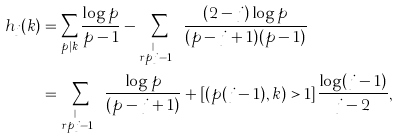Convert formula to latex. <formula><loc_0><loc_0><loc_500><loc_500>h _ { j } ( k ) & = \sum _ { p | k } \frac { \log p } { p - 1 } - \sum _ { \stackrel { r p | k } { r p \neq j - 1 } } \frac { ( 2 - j ) \log p } { ( p - j + 1 ) ( p - 1 ) } \\ & = \sum _ { \stackrel { r p | k } { r p \neq j - 1 } } \frac { \log p } { ( p - j + 1 ) } + [ ( p ( j - 1 ) , k ) > 1 ] \frac { \log ( j - 1 ) } { j - 2 } ,</formula> 